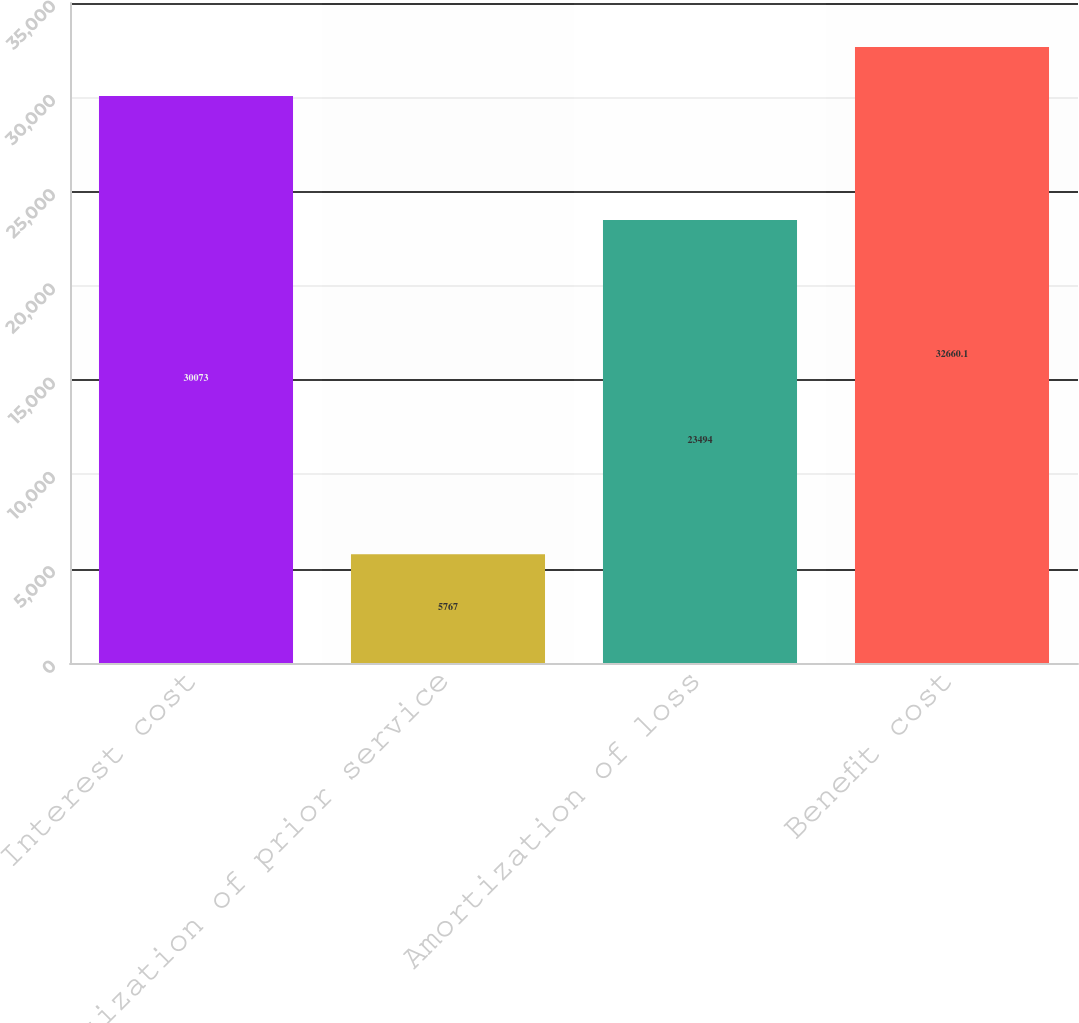Convert chart. <chart><loc_0><loc_0><loc_500><loc_500><bar_chart><fcel>Interest cost<fcel>Amortization of prior service<fcel>Amortization of loss<fcel>Benefit cost<nl><fcel>30073<fcel>5767<fcel>23494<fcel>32660.1<nl></chart> 